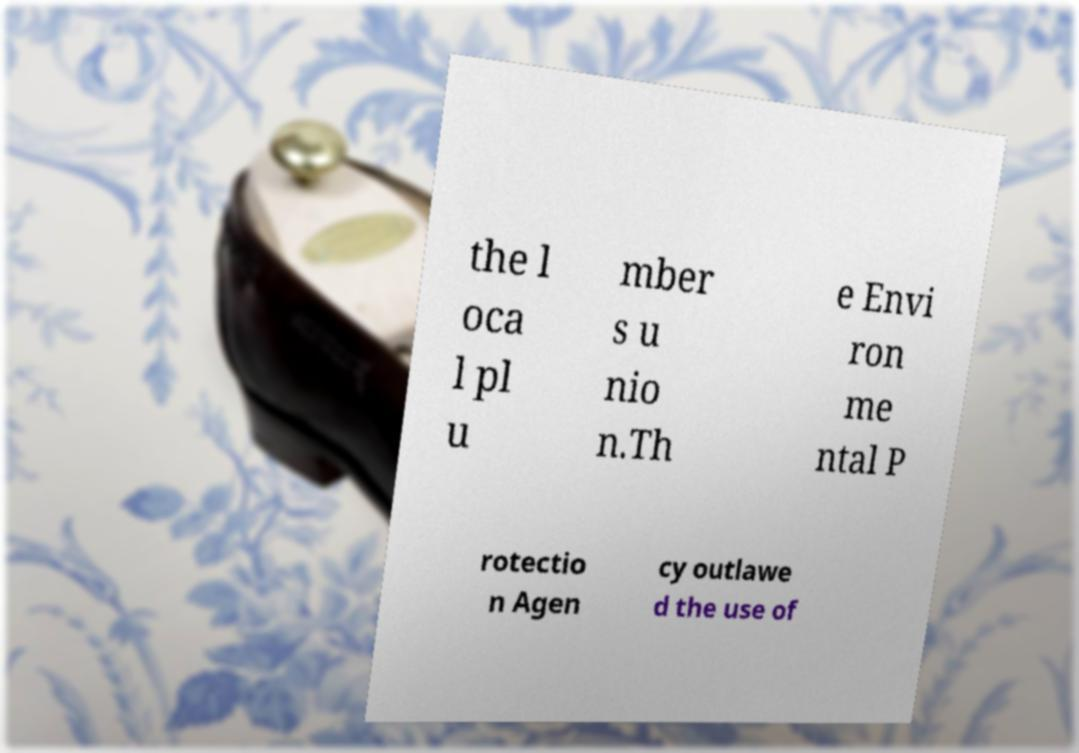For documentation purposes, I need the text within this image transcribed. Could you provide that? the l oca l pl u mber s u nio n.Th e Envi ron me ntal P rotectio n Agen cy outlawe d the use of 